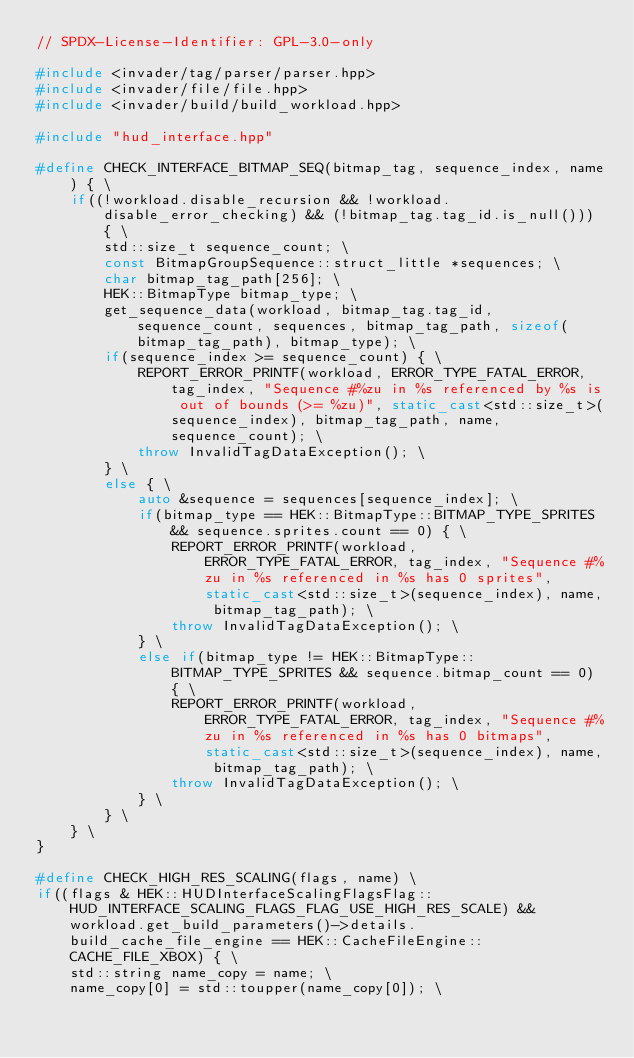Convert code to text. <code><loc_0><loc_0><loc_500><loc_500><_C++_>// SPDX-License-Identifier: GPL-3.0-only

#include <invader/tag/parser/parser.hpp>
#include <invader/file/file.hpp>
#include <invader/build/build_workload.hpp>

#include "hud_interface.hpp"

#define CHECK_INTERFACE_BITMAP_SEQ(bitmap_tag, sequence_index, name) { \
    if((!workload.disable_recursion && !workload.disable_error_checking) && (!bitmap_tag.tag_id.is_null())) { \
        std::size_t sequence_count; \
        const BitmapGroupSequence::struct_little *sequences; \
        char bitmap_tag_path[256]; \
        HEK::BitmapType bitmap_type; \
        get_sequence_data(workload, bitmap_tag.tag_id, sequence_count, sequences, bitmap_tag_path, sizeof(bitmap_tag_path), bitmap_type); \
        if(sequence_index >= sequence_count) { \
            REPORT_ERROR_PRINTF(workload, ERROR_TYPE_FATAL_ERROR, tag_index, "Sequence #%zu in %s referenced by %s is out of bounds (>= %zu)", static_cast<std::size_t>(sequence_index), bitmap_tag_path, name, sequence_count); \
            throw InvalidTagDataException(); \
        } \
        else { \
            auto &sequence = sequences[sequence_index]; \
            if(bitmap_type == HEK::BitmapType::BITMAP_TYPE_SPRITES && sequence.sprites.count == 0) { \
                REPORT_ERROR_PRINTF(workload, ERROR_TYPE_FATAL_ERROR, tag_index, "Sequence #%zu in %s referenced in %s has 0 sprites", static_cast<std::size_t>(sequence_index), name, bitmap_tag_path); \
                throw InvalidTagDataException(); \
            } \
            else if(bitmap_type != HEK::BitmapType::BITMAP_TYPE_SPRITES && sequence.bitmap_count == 0) { \
                REPORT_ERROR_PRINTF(workload, ERROR_TYPE_FATAL_ERROR, tag_index, "Sequence #%zu in %s referenced in %s has 0 bitmaps", static_cast<std::size_t>(sequence_index), name, bitmap_tag_path); \
                throw InvalidTagDataException(); \
            } \
        } \
    } \
}
        
#define CHECK_HIGH_RES_SCALING(flags, name) \
if((flags & HEK::HUDInterfaceScalingFlagsFlag::HUD_INTERFACE_SCALING_FLAGS_FLAG_USE_HIGH_RES_SCALE) && workload.get_build_parameters()->details.build_cache_file_engine == HEK::CacheFileEngine::CACHE_FILE_XBOX) { \
    std::string name_copy = name; \
    name_copy[0] = std::toupper(name_copy[0]); \</code> 